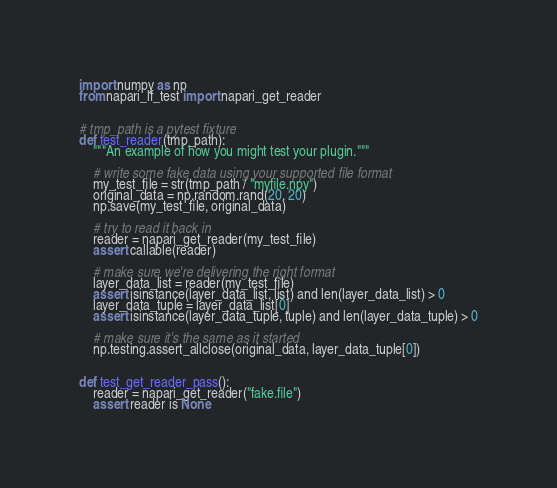<code> <loc_0><loc_0><loc_500><loc_500><_Python_>import numpy as np
from napari_lf_test import napari_get_reader


# tmp_path is a pytest fixture
def test_reader(tmp_path):
    """An example of how you might test your plugin."""

    # write some fake data using your supported file format
    my_test_file = str(tmp_path / "myfile.npy")
    original_data = np.random.rand(20, 20)
    np.save(my_test_file, original_data)

    # try to read it back in
    reader = napari_get_reader(my_test_file)
    assert callable(reader)

    # make sure we're delivering the right format
    layer_data_list = reader(my_test_file)
    assert isinstance(layer_data_list, list) and len(layer_data_list) > 0
    layer_data_tuple = layer_data_list[0]
    assert isinstance(layer_data_tuple, tuple) and len(layer_data_tuple) > 0

    # make sure it's the same as it started
    np.testing.assert_allclose(original_data, layer_data_tuple[0])


def test_get_reader_pass():
    reader = napari_get_reader("fake.file")
    assert reader is None
</code> 